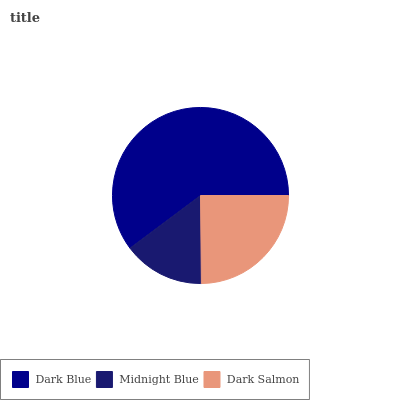Is Midnight Blue the minimum?
Answer yes or no. Yes. Is Dark Blue the maximum?
Answer yes or no. Yes. Is Dark Salmon the minimum?
Answer yes or no. No. Is Dark Salmon the maximum?
Answer yes or no. No. Is Dark Salmon greater than Midnight Blue?
Answer yes or no. Yes. Is Midnight Blue less than Dark Salmon?
Answer yes or no. Yes. Is Midnight Blue greater than Dark Salmon?
Answer yes or no. No. Is Dark Salmon less than Midnight Blue?
Answer yes or no. No. Is Dark Salmon the high median?
Answer yes or no. Yes. Is Dark Salmon the low median?
Answer yes or no. Yes. Is Midnight Blue the high median?
Answer yes or no. No. Is Dark Blue the low median?
Answer yes or no. No. 